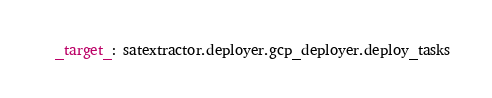<code> <loc_0><loc_0><loc_500><loc_500><_YAML_>_target_: satextractor.deployer.gcp_deployer.deploy_tasks
</code> 